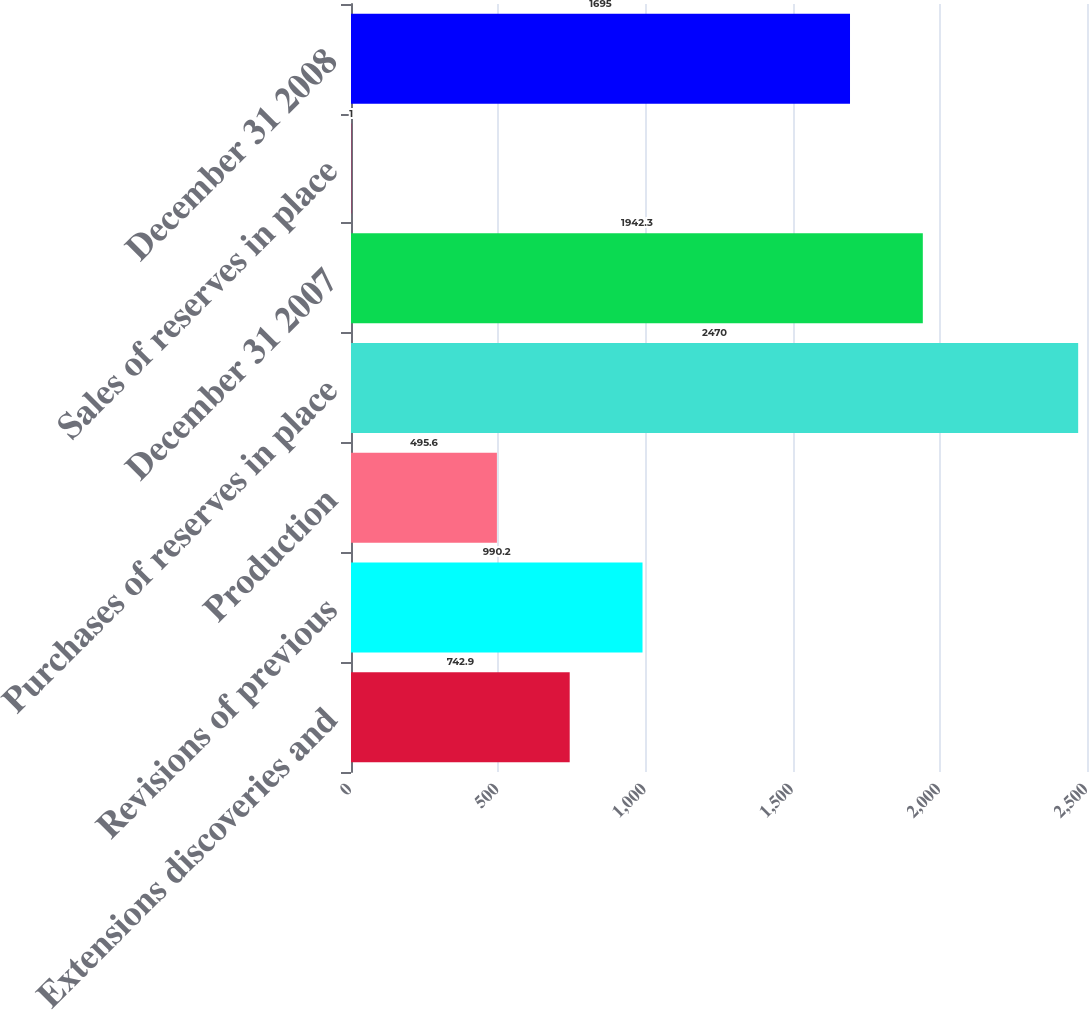<chart> <loc_0><loc_0><loc_500><loc_500><bar_chart><fcel>Extensions discoveries and<fcel>Revisions of previous<fcel>Production<fcel>Purchases of reserves in place<fcel>December 31 2007<fcel>Sales of reserves in place<fcel>December 31 2008<nl><fcel>742.9<fcel>990.2<fcel>495.6<fcel>2470<fcel>1942.3<fcel>1<fcel>1695<nl></chart> 